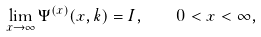<formula> <loc_0><loc_0><loc_500><loc_500>\lim _ { x \to \infty } \Psi ^ { ( x ) } ( x , k ) = I , \quad 0 < x < \infty ,</formula> 